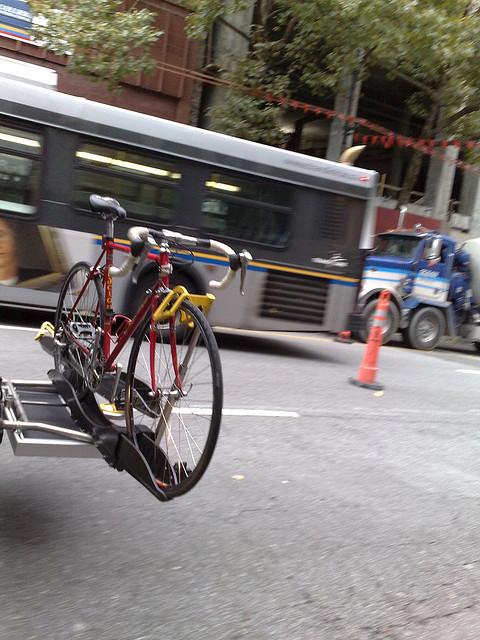What color are the cones?
Write a very short answer. Orange. What is the bike on?
Short answer required. Bus. What color is the bike?
Give a very brief answer. Red. 